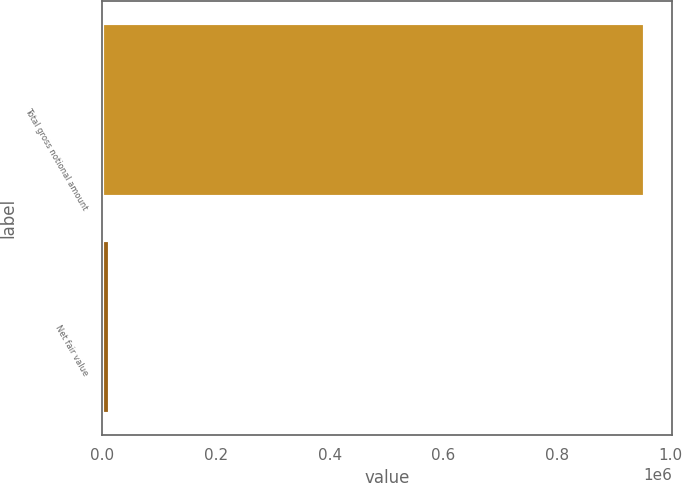<chart> <loc_0><loc_0><loc_500><loc_500><bar_chart><fcel>Total gross notional amount<fcel>Net fair value<nl><fcel>955139<fcel>14052<nl></chart> 